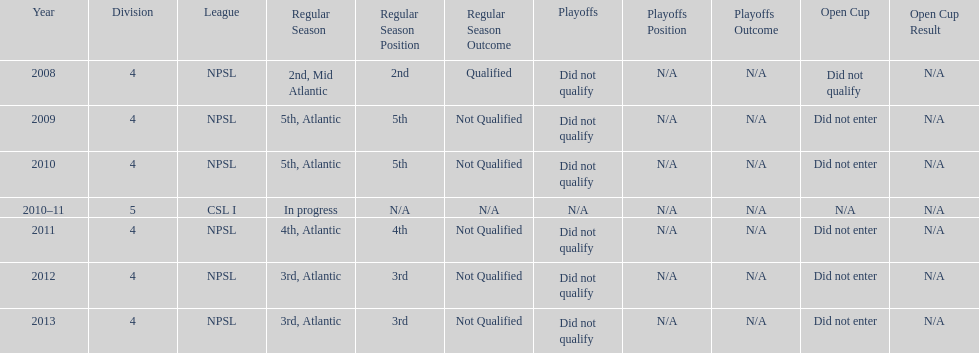What was the last year they were 5th? 2010. 